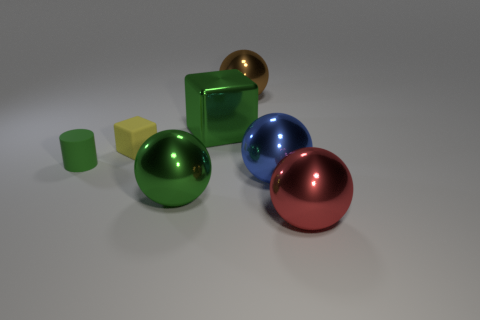There is a brown shiny thing that is the same size as the red object; what shape is it?
Your answer should be compact. Sphere. What color is the cube right of the sphere left of the shiny ball that is behind the tiny green matte object?
Give a very brief answer. Green. Is the shape of the big brown metal object the same as the blue object?
Make the answer very short. Yes. Are there the same number of large red metallic things in front of the blue shiny object and balls?
Make the answer very short. No. What number of other things are there of the same material as the large green sphere
Your answer should be very brief. 4. There is a shiny sphere that is to the right of the large blue ball; does it have the same size as the block to the right of the tiny yellow matte object?
Your response must be concise. Yes. How many objects are either shiny objects in front of the large block or metal things that are behind the shiny block?
Your answer should be very brief. 4. Are there any other things that are the same shape as the large brown object?
Keep it short and to the point. Yes. There is a large sphere behind the small green matte cylinder; is it the same color as the ball on the left side of the big brown shiny thing?
Keep it short and to the point. No. How many matte objects are green things or big blue balls?
Provide a short and direct response. 1. 